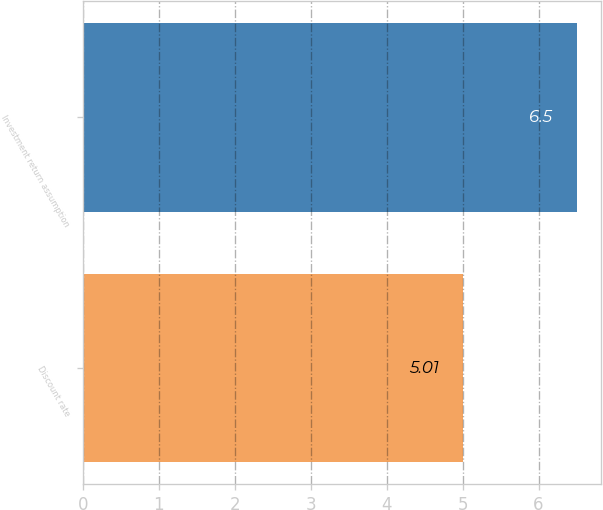Convert chart to OTSL. <chart><loc_0><loc_0><loc_500><loc_500><bar_chart><fcel>Discount rate<fcel>Investment return assumption<nl><fcel>5.01<fcel>6.5<nl></chart> 